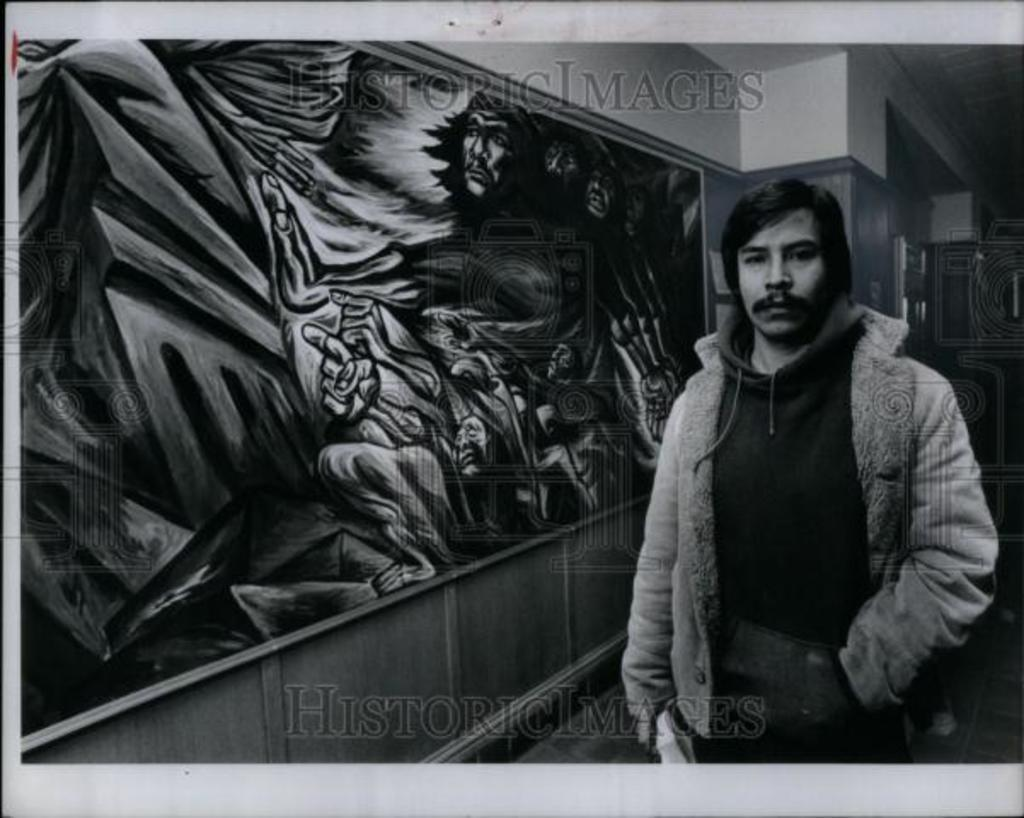What is the person in the image doing? The person is standing on the right side of the image and watching something. What is the person holding in the image? The person is holding an object in the image. What can be seen in the background of the image? There is a painting and a wall in the background of the image. Are there any visible marks on the image? Yes, there are watermarks visible in the image. What type of thunder can be heard in the image? There is no sound present in the image, so it is not possible to determine if thunder can be heard. 